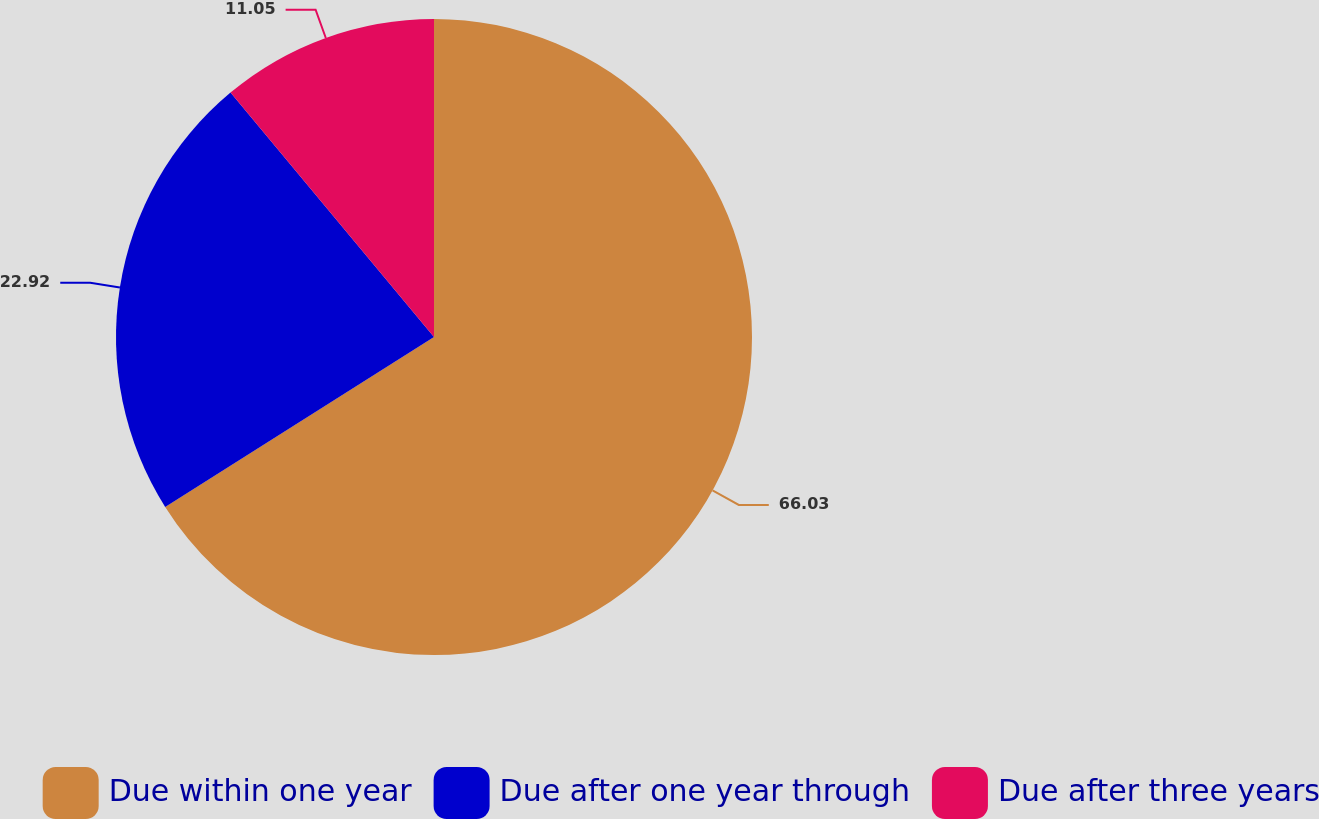Convert chart to OTSL. <chart><loc_0><loc_0><loc_500><loc_500><pie_chart><fcel>Due within one year<fcel>Due after one year through<fcel>Due after three years<nl><fcel>66.03%<fcel>22.92%<fcel>11.05%<nl></chart> 